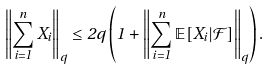<formula> <loc_0><loc_0><loc_500><loc_500>\left \| \sum _ { i = 1 } ^ { n } X _ { i } \right \| _ { q } \leq 2 q \left ( 1 + \left \| \sum _ { i = 1 } ^ { n } \mathbb { E } [ X _ { i } | \mathcal { F } ] \right \| _ { q } \right ) .</formula> 